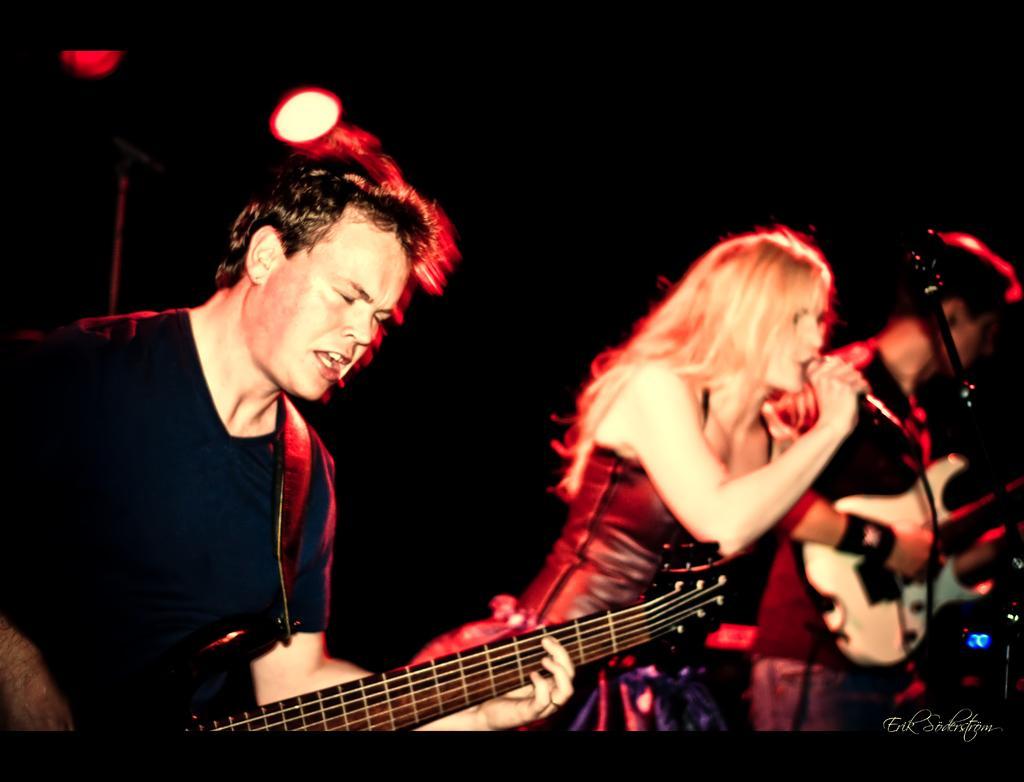In one or two sentences, can you explain what this image depicts? On the left there is a man who is wearing t-shirt and playing guitar. Here we can see a woman who is wearing black dress and she is holding mic and she is singing. Beside her we can see another man who is playing electric guitar. Near to him we can see a mic stand. On the top we can see darkness. Here we can see lights. On the bottom right corner there is a watermark. 